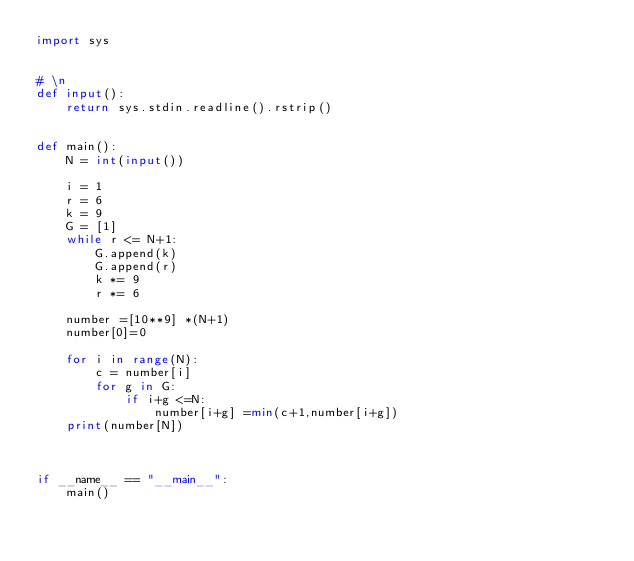Convert code to text. <code><loc_0><loc_0><loc_500><loc_500><_Python_>import sys


# \n
def input():
    return sys.stdin.readline().rstrip()


def main():
    N = int(input())

    i = 1
    r = 6
    k = 9
    G = [1]
    while r <= N+1:
        G.append(k)
        G.append(r)
        k *= 9
        r *= 6

    number =[10**9] *(N+1)
    number[0]=0

    for i in range(N):
        c = number[i]
        for g in G:
            if i+g <=N:
                number[i+g] =min(c+1,number[i+g])
    print(number[N])



if __name__ == "__main__":
    main()
</code> 